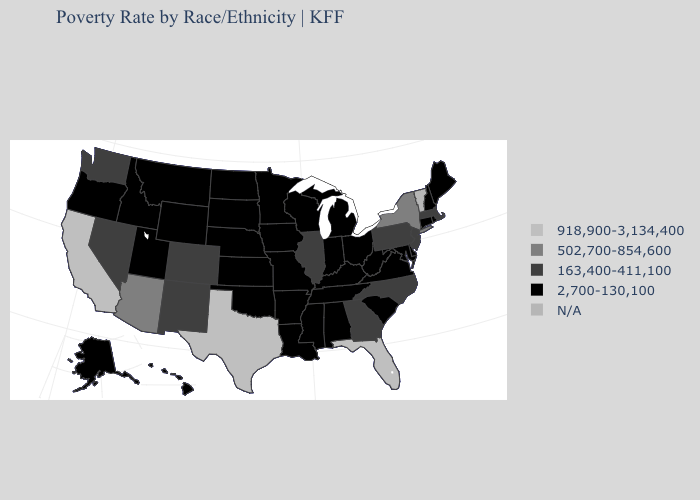Name the states that have a value in the range 2,700-130,100?
Give a very brief answer. Alabama, Alaska, Arkansas, Connecticut, Delaware, Hawaii, Idaho, Indiana, Iowa, Kansas, Kentucky, Louisiana, Maine, Maryland, Michigan, Minnesota, Mississippi, Missouri, Montana, Nebraska, New Hampshire, North Dakota, Ohio, Oklahoma, Oregon, Rhode Island, South Carolina, South Dakota, Tennessee, Utah, Virginia, West Virginia, Wisconsin, Wyoming. Name the states that have a value in the range N/A?
Keep it brief. Vermont. Name the states that have a value in the range 918,900-3,134,400?
Answer briefly. California, Florida, Texas. What is the value of Florida?
Write a very short answer. 918,900-3,134,400. What is the highest value in the MidWest ?
Give a very brief answer. 163,400-411,100. Does North Dakota have the highest value in the MidWest?
Short answer required. No. Which states hav the highest value in the South?
Answer briefly. Florida, Texas. What is the value of Tennessee?
Quick response, please. 2,700-130,100. What is the value of Massachusetts?
Write a very short answer. 163,400-411,100. Is the legend a continuous bar?
Concise answer only. No. What is the highest value in states that border Delaware?
Give a very brief answer. 163,400-411,100. What is the highest value in the USA?
Quick response, please. 918,900-3,134,400. What is the value of Pennsylvania?
Keep it brief. 163,400-411,100. Name the states that have a value in the range 163,400-411,100?
Keep it brief. Colorado, Georgia, Illinois, Massachusetts, Nevada, New Jersey, New Mexico, North Carolina, Pennsylvania, Washington. 